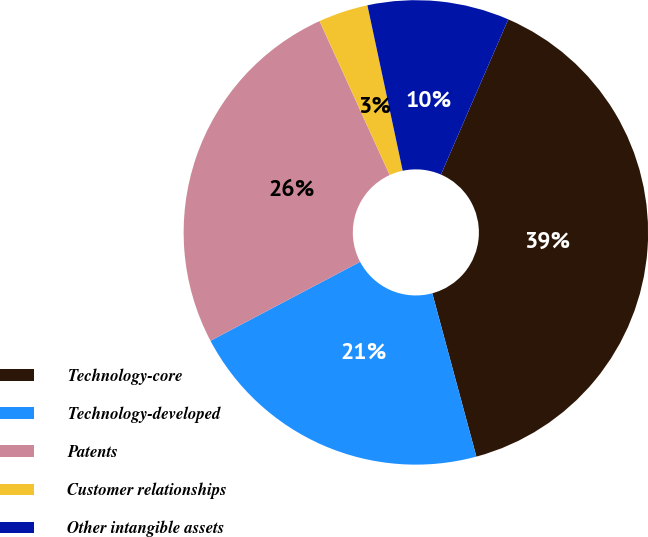Convert chart. <chart><loc_0><loc_0><loc_500><loc_500><pie_chart><fcel>Technology-core<fcel>Technology-developed<fcel>Patents<fcel>Customer relationships<fcel>Other intangible assets<nl><fcel>39.29%<fcel>21.47%<fcel>25.92%<fcel>3.46%<fcel>9.86%<nl></chart> 